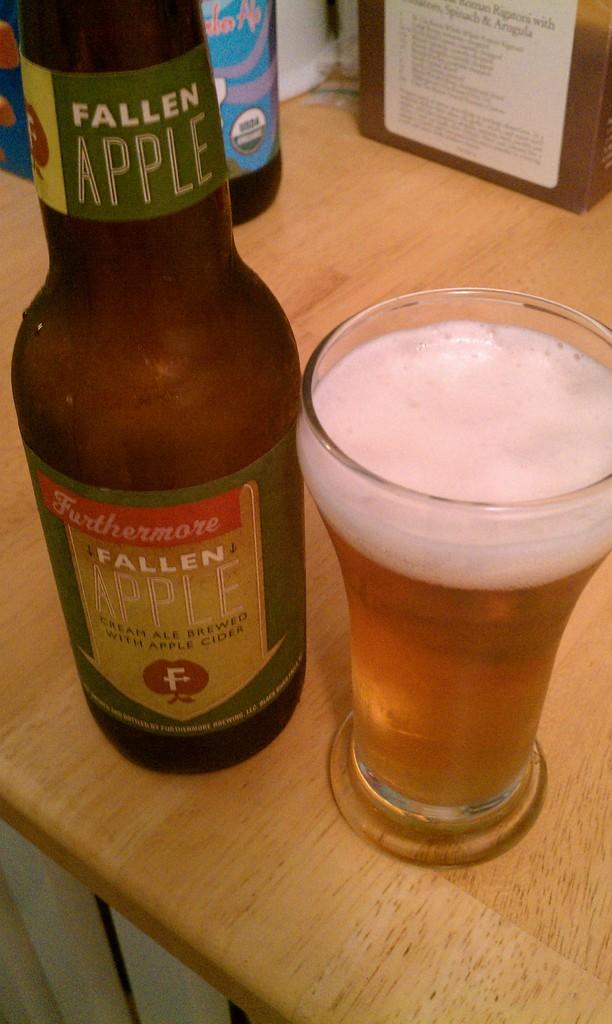What flavor is this beer?
Your answer should be compact. Apple. What is the brand?
Provide a succinct answer. Fallen apple. 